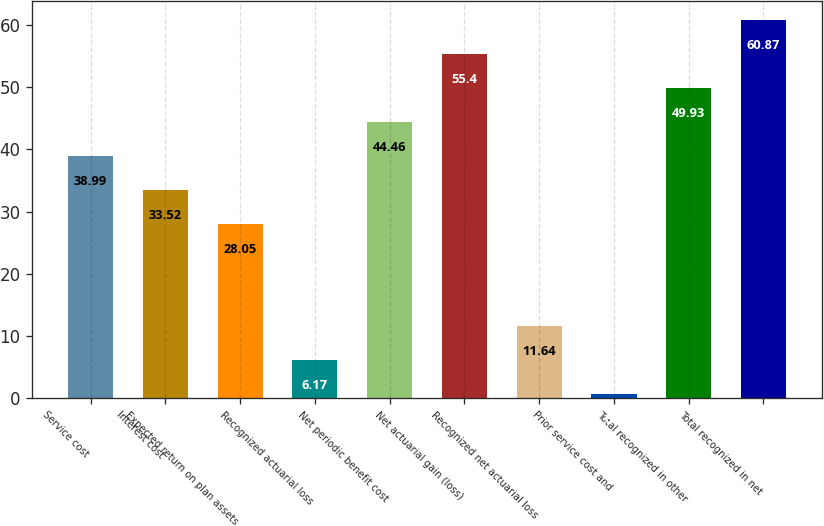Convert chart to OTSL. <chart><loc_0><loc_0><loc_500><loc_500><bar_chart><fcel>Service cost<fcel>Interest cost<fcel>Expected return on plan assets<fcel>Recognized actuarial loss<fcel>Net periodic benefit cost<fcel>Net actuarial gain (loss)<fcel>Recognized net actuarial loss<fcel>Prior service cost and<fcel>Total recognized in other<fcel>Total recognized in net<nl><fcel>38.99<fcel>33.52<fcel>28.05<fcel>6.17<fcel>44.46<fcel>55.4<fcel>11.64<fcel>0.7<fcel>49.93<fcel>60.87<nl></chart> 